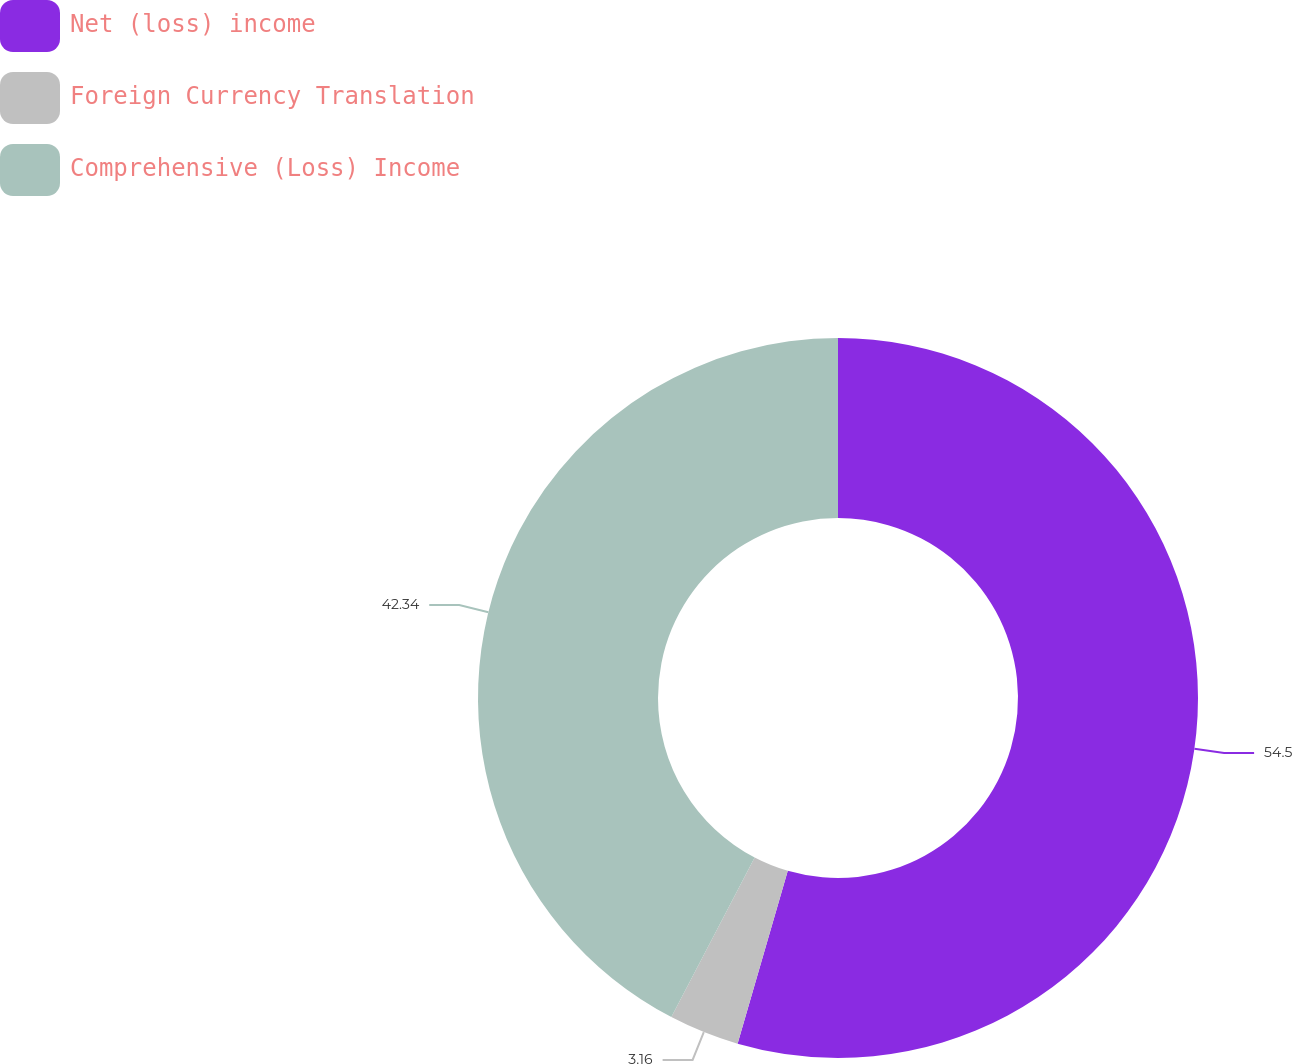<chart> <loc_0><loc_0><loc_500><loc_500><pie_chart><fcel>Net (loss) income<fcel>Foreign Currency Translation<fcel>Comprehensive (Loss) Income<nl><fcel>54.5%<fcel>3.16%<fcel>42.34%<nl></chart> 